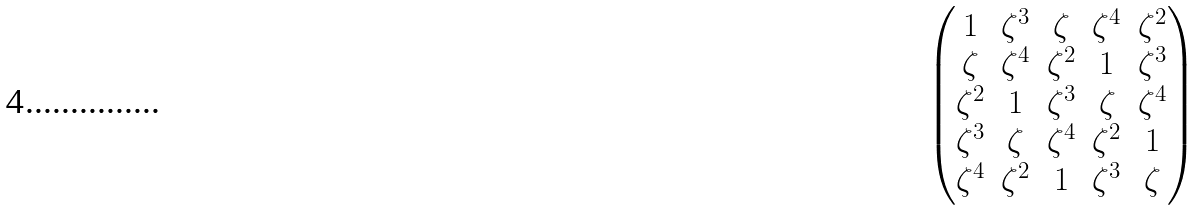<formula> <loc_0><loc_0><loc_500><loc_500>\begin{pmatrix} 1 & \zeta ^ { 3 } & \zeta & \zeta ^ { 4 } & \zeta ^ { 2 } \\ \zeta & \zeta ^ { 4 } & \zeta ^ { 2 } & 1 & \zeta ^ { 3 } \\ \zeta ^ { 2 } & 1 & \zeta ^ { 3 } & \zeta & \zeta ^ { 4 } \\ \zeta ^ { 3 } & \zeta & \zeta ^ { 4 } & \zeta ^ { 2 } & 1 \\ \zeta ^ { 4 } & \zeta ^ { 2 } & 1 & \zeta ^ { 3 } & \zeta \end{pmatrix}</formula> 